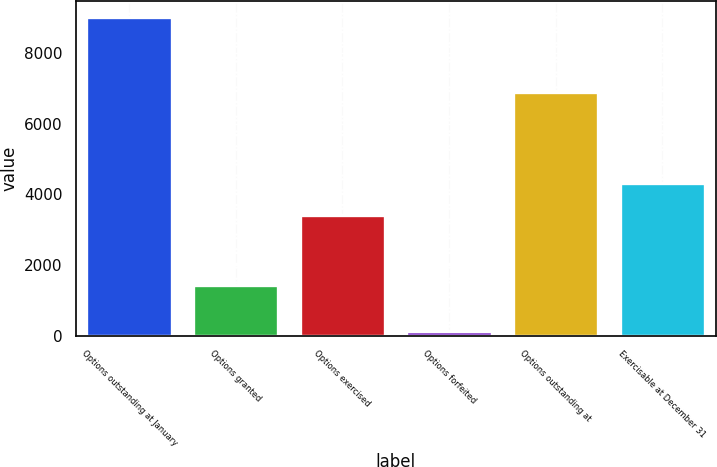<chart> <loc_0><loc_0><loc_500><loc_500><bar_chart><fcel>Options outstanding at January<fcel>Options granted<fcel>Options exercised<fcel>Options forfeited<fcel>Options outstanding at<fcel>Exercisable at December 31<nl><fcel>9029<fcel>1419<fcel>3418<fcel>135<fcel>6895<fcel>4307.4<nl></chart> 